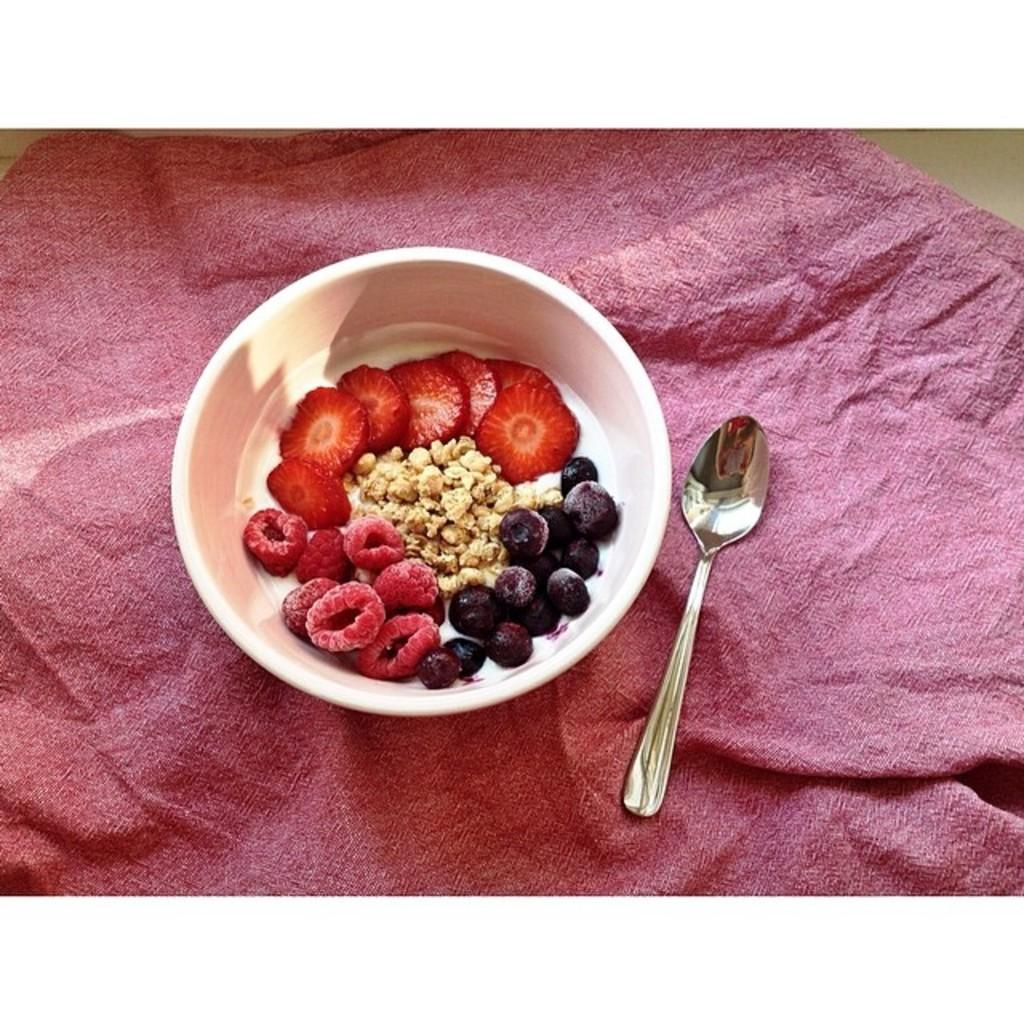What type of food items are in the bowl in the image? There are nutrition fruit items in the bowl. What utensil is visible in the image? There is a spoon visible in the image. What is on the floor in the image? There is a cloth on the floor. How many eggs are present in the image? There are no eggs visible in the image. 